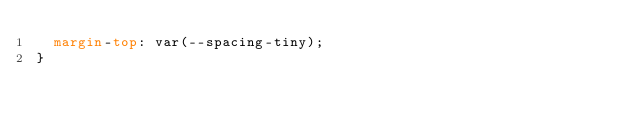<code> <loc_0><loc_0><loc_500><loc_500><_CSS_>  margin-top: var(--spacing-tiny);
}
</code> 